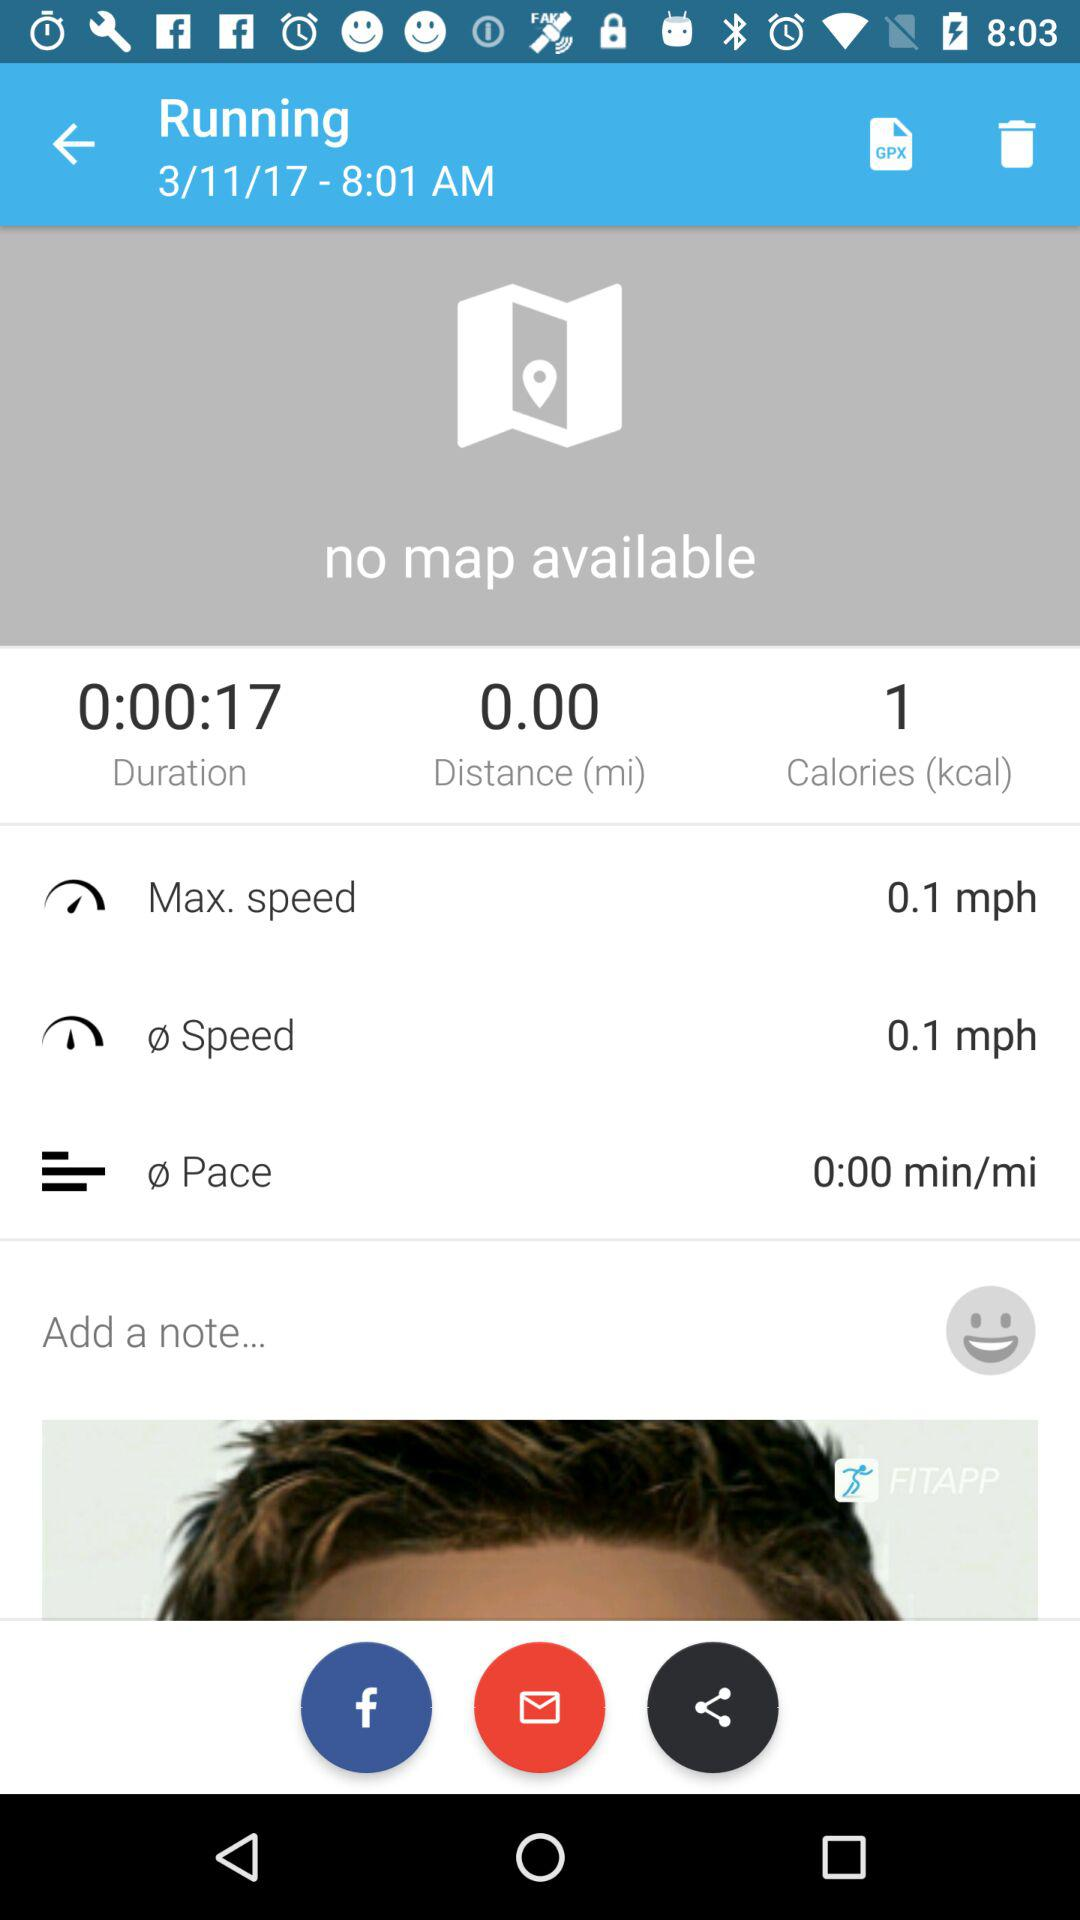What is the maximum speed? The maximum speed is 0.1 mph. 